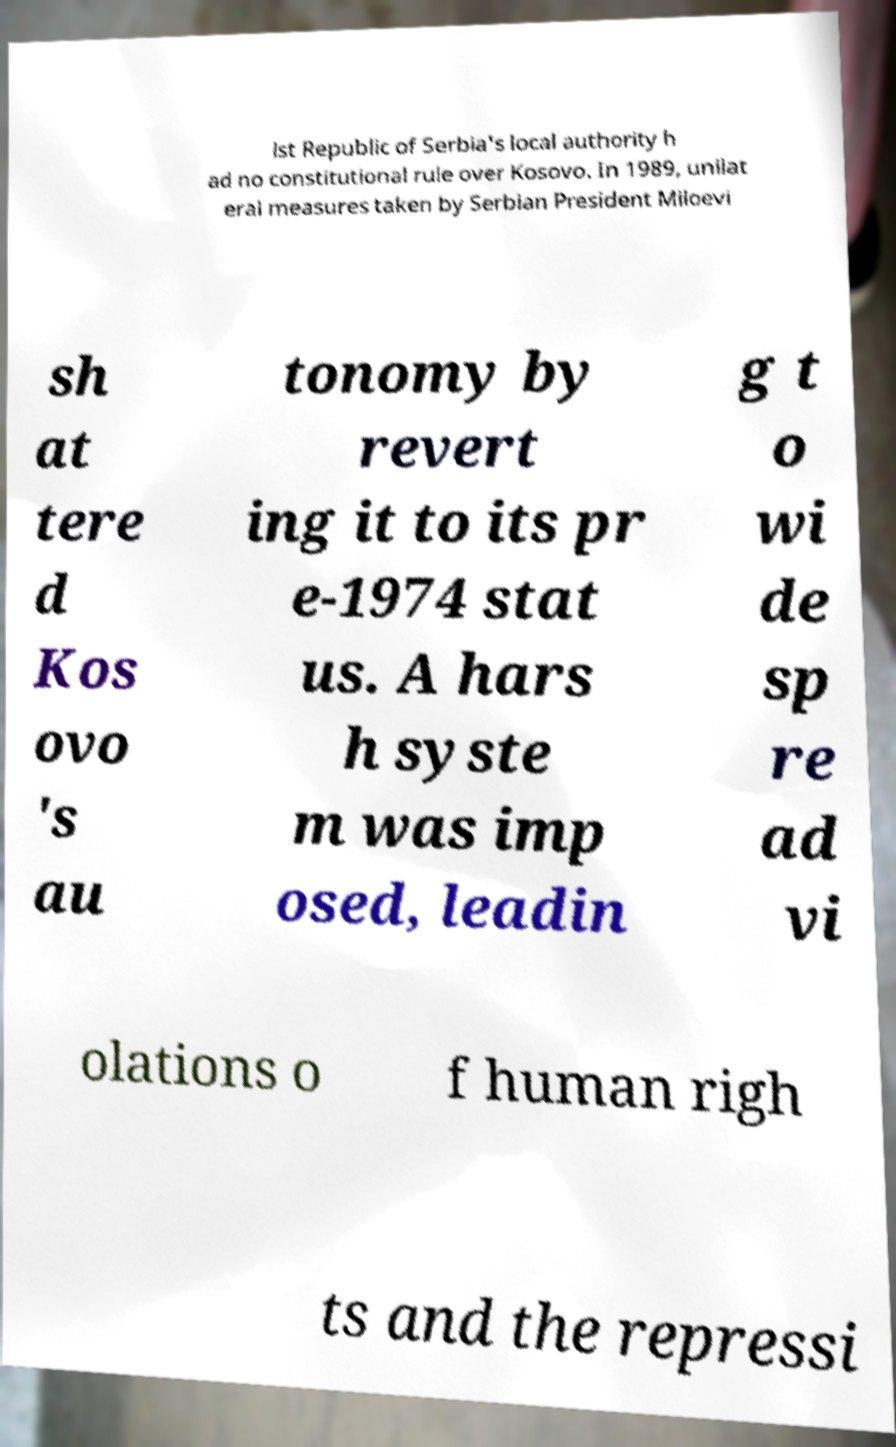Can you accurately transcribe the text from the provided image for me? ist Republic of Serbia's local authority h ad no constitutional rule over Kosovo. In 1989, unilat eral measures taken by Serbian President Miloevi sh at tere d Kos ovo 's au tonomy by revert ing it to its pr e-1974 stat us. A hars h syste m was imp osed, leadin g t o wi de sp re ad vi olations o f human righ ts and the repressi 